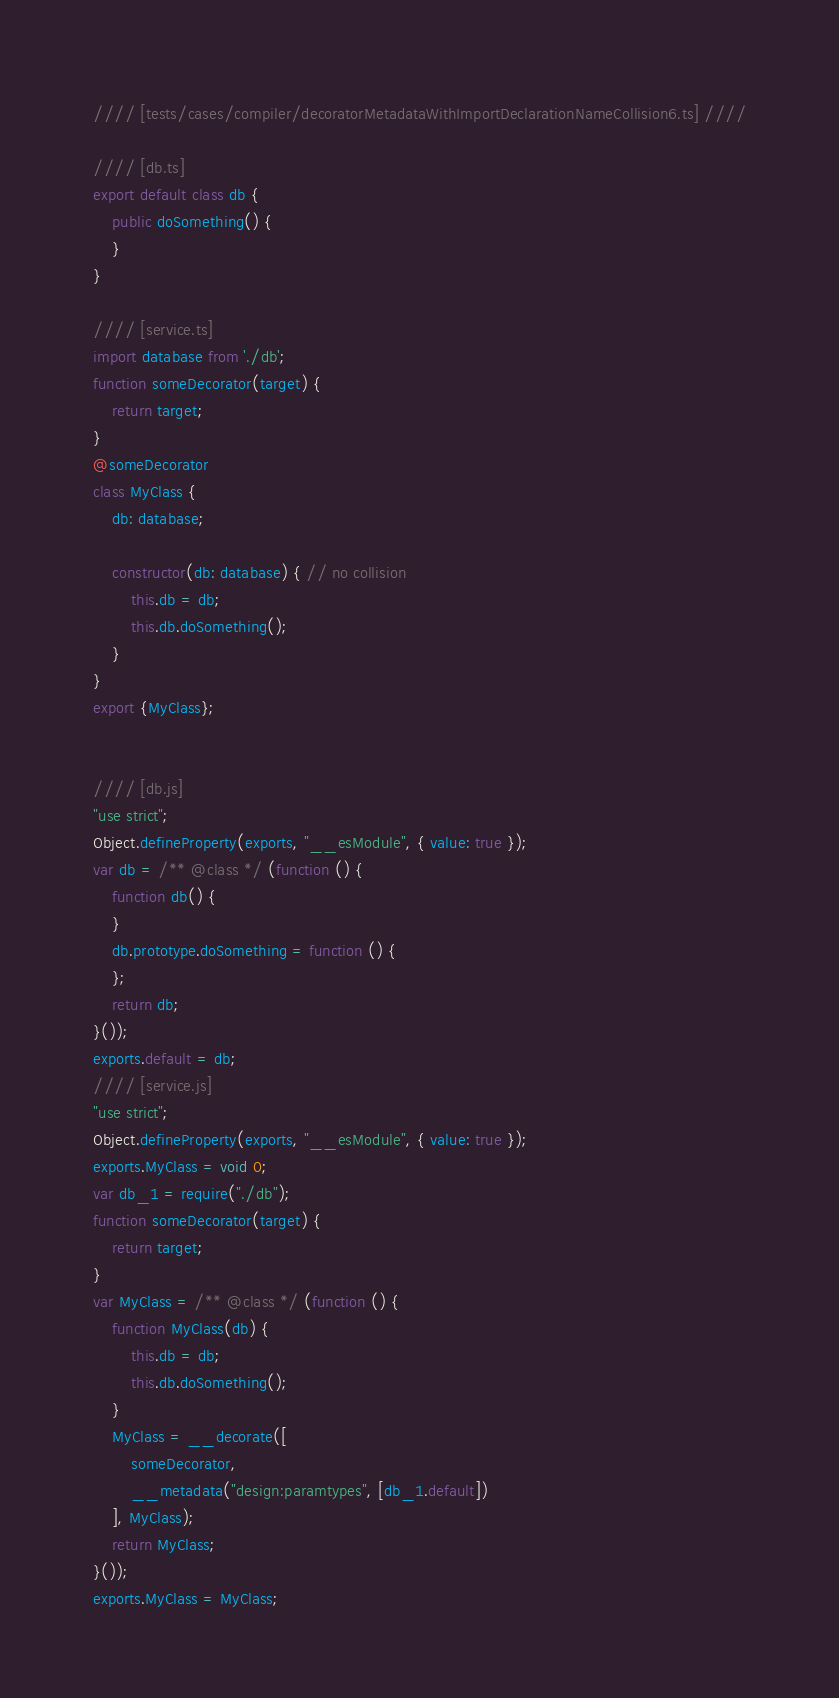Convert code to text. <code><loc_0><loc_0><loc_500><loc_500><_JavaScript_>//// [tests/cases/compiler/decoratorMetadataWithImportDeclarationNameCollision6.ts] ////

//// [db.ts]
export default class db {
    public doSomething() {
    }
}

//// [service.ts]
import database from './db';
function someDecorator(target) {
    return target;
}
@someDecorator
class MyClass {
    db: database;

    constructor(db: database) { // no collision
        this.db = db;
        this.db.doSomething();
    }
}
export {MyClass};


//// [db.js]
"use strict";
Object.defineProperty(exports, "__esModule", { value: true });
var db = /** @class */ (function () {
    function db() {
    }
    db.prototype.doSomething = function () {
    };
    return db;
}());
exports.default = db;
//// [service.js]
"use strict";
Object.defineProperty(exports, "__esModule", { value: true });
exports.MyClass = void 0;
var db_1 = require("./db");
function someDecorator(target) {
    return target;
}
var MyClass = /** @class */ (function () {
    function MyClass(db) {
        this.db = db;
        this.db.doSomething();
    }
    MyClass = __decorate([
        someDecorator,
        __metadata("design:paramtypes", [db_1.default])
    ], MyClass);
    return MyClass;
}());
exports.MyClass = MyClass;
</code> 